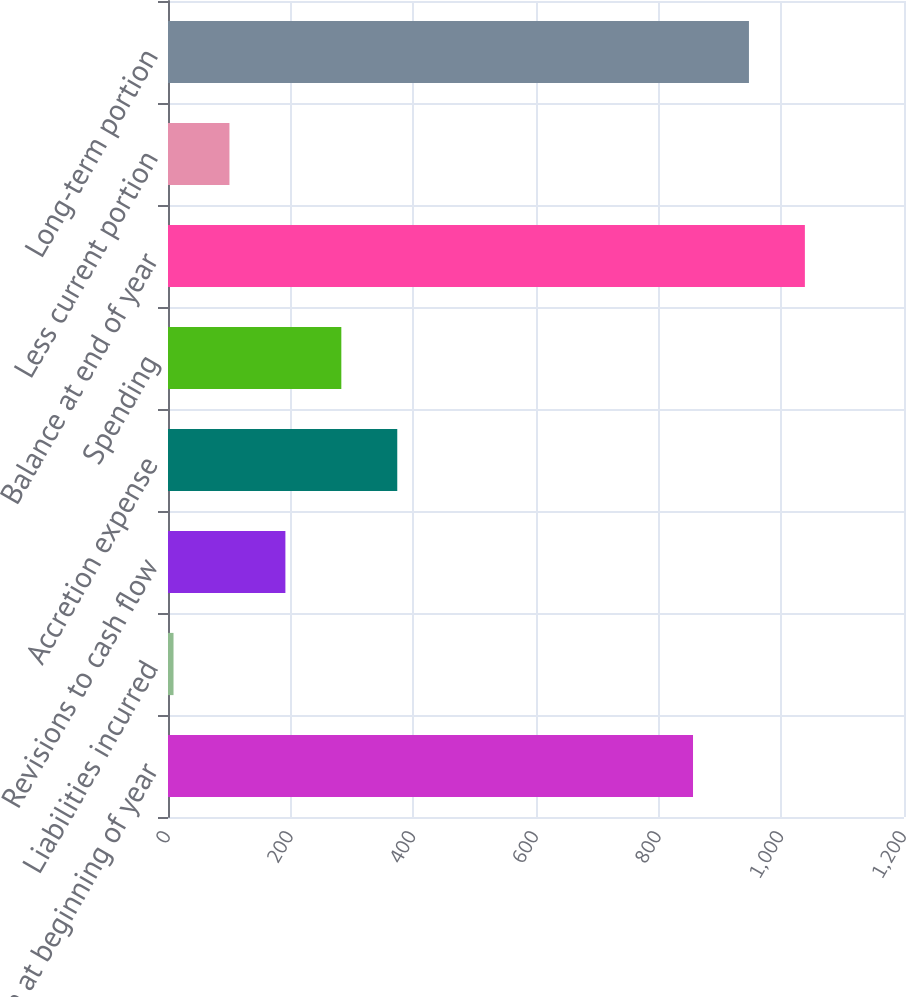Convert chart. <chart><loc_0><loc_0><loc_500><loc_500><bar_chart><fcel>Balance at beginning of year<fcel>Liabilities incurred<fcel>Revisions to cash flow<fcel>Accretion expense<fcel>Spending<fcel>Balance at end of year<fcel>Less current portion<fcel>Long-term portion<nl><fcel>856<fcel>9<fcel>191.4<fcel>373.8<fcel>282.6<fcel>1038.4<fcel>100.2<fcel>947.2<nl></chart> 